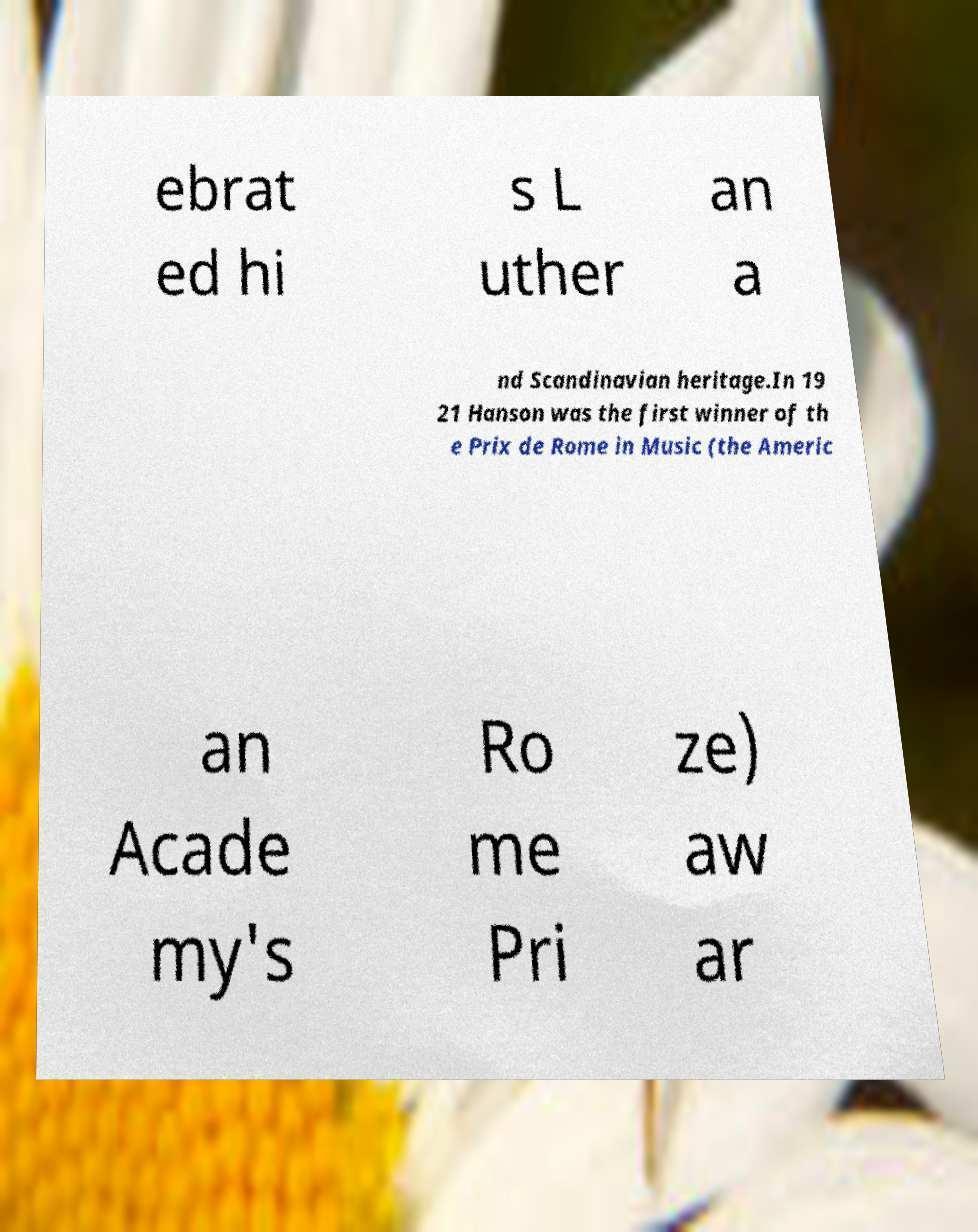Please identify and transcribe the text found in this image. ebrat ed hi s L uther an a nd Scandinavian heritage.In 19 21 Hanson was the first winner of th e Prix de Rome in Music (the Americ an Acade my's Ro me Pri ze) aw ar 